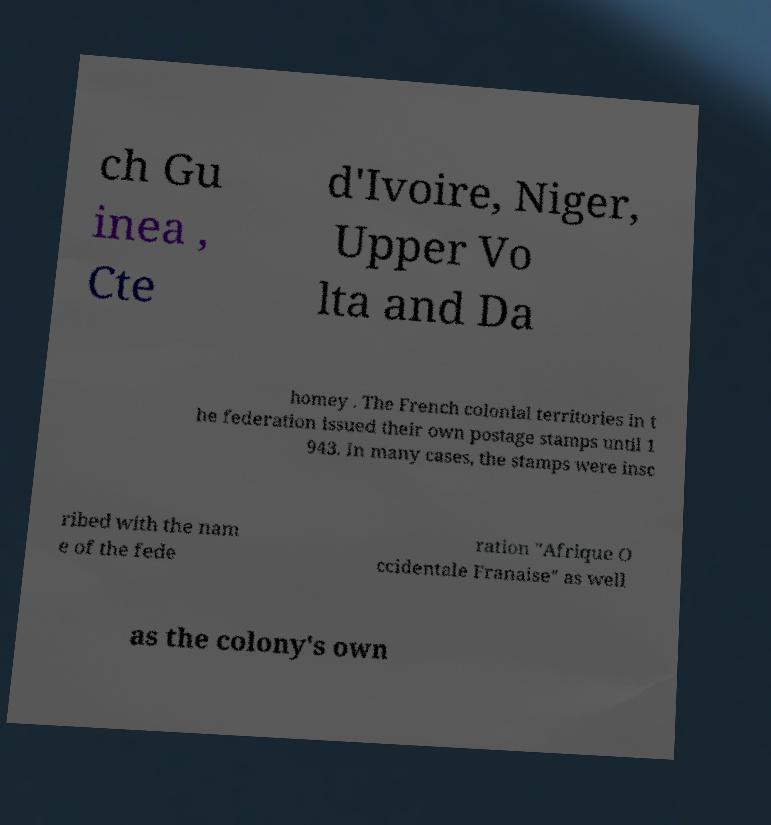I need the written content from this picture converted into text. Can you do that? ch Gu inea , Cte d'Ivoire, Niger, Upper Vo lta and Da homey . The French colonial territories in t he federation issued their own postage stamps until 1 943. In many cases, the stamps were insc ribed with the nam e of the fede ration "Afrique O ccidentale Franaise" as well as the colony's own 